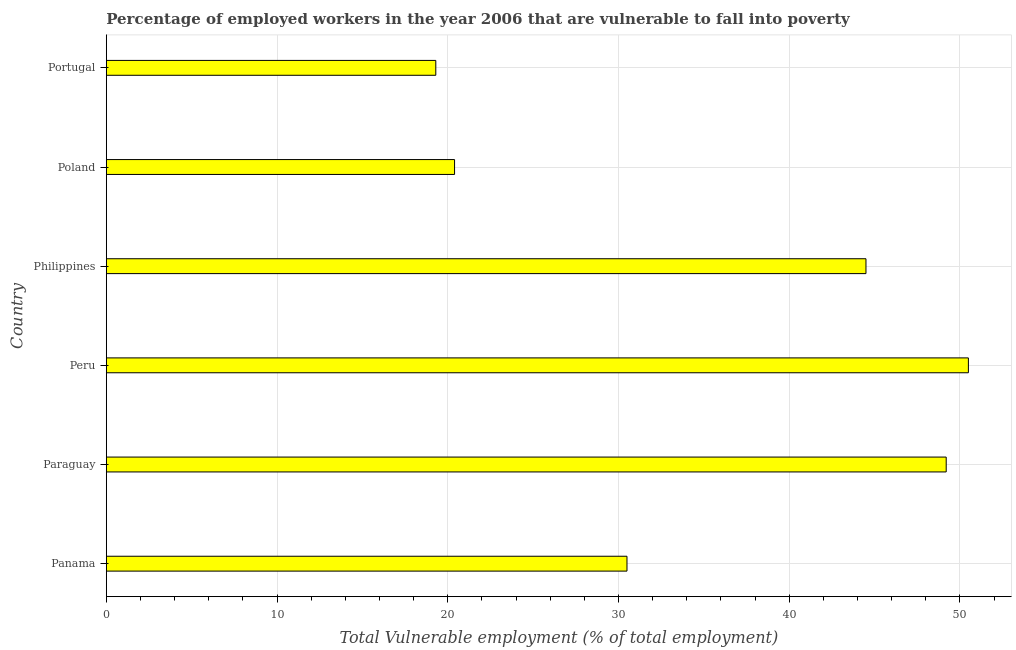Does the graph contain grids?
Offer a terse response. Yes. What is the title of the graph?
Make the answer very short. Percentage of employed workers in the year 2006 that are vulnerable to fall into poverty. What is the label or title of the X-axis?
Offer a very short reply. Total Vulnerable employment (% of total employment). What is the total vulnerable employment in Peru?
Offer a very short reply. 50.5. Across all countries, what is the maximum total vulnerable employment?
Your response must be concise. 50.5. Across all countries, what is the minimum total vulnerable employment?
Ensure brevity in your answer.  19.3. What is the sum of the total vulnerable employment?
Provide a succinct answer. 214.4. What is the average total vulnerable employment per country?
Ensure brevity in your answer.  35.73. What is the median total vulnerable employment?
Your response must be concise. 37.5. What is the difference between the highest and the second highest total vulnerable employment?
Your answer should be very brief. 1.3. Is the sum of the total vulnerable employment in Panama and Poland greater than the maximum total vulnerable employment across all countries?
Offer a very short reply. Yes. What is the difference between the highest and the lowest total vulnerable employment?
Your answer should be compact. 31.2. In how many countries, is the total vulnerable employment greater than the average total vulnerable employment taken over all countries?
Ensure brevity in your answer.  3. Are all the bars in the graph horizontal?
Ensure brevity in your answer.  Yes. Are the values on the major ticks of X-axis written in scientific E-notation?
Give a very brief answer. No. What is the Total Vulnerable employment (% of total employment) in Panama?
Provide a succinct answer. 30.5. What is the Total Vulnerable employment (% of total employment) in Paraguay?
Provide a short and direct response. 49.2. What is the Total Vulnerable employment (% of total employment) in Peru?
Make the answer very short. 50.5. What is the Total Vulnerable employment (% of total employment) of Philippines?
Your response must be concise. 44.5. What is the Total Vulnerable employment (% of total employment) in Poland?
Provide a succinct answer. 20.4. What is the Total Vulnerable employment (% of total employment) in Portugal?
Provide a short and direct response. 19.3. What is the difference between the Total Vulnerable employment (% of total employment) in Panama and Paraguay?
Provide a short and direct response. -18.7. What is the difference between the Total Vulnerable employment (% of total employment) in Panama and Peru?
Your answer should be compact. -20. What is the difference between the Total Vulnerable employment (% of total employment) in Paraguay and Philippines?
Offer a terse response. 4.7. What is the difference between the Total Vulnerable employment (% of total employment) in Paraguay and Poland?
Make the answer very short. 28.8. What is the difference between the Total Vulnerable employment (% of total employment) in Paraguay and Portugal?
Make the answer very short. 29.9. What is the difference between the Total Vulnerable employment (% of total employment) in Peru and Philippines?
Provide a short and direct response. 6. What is the difference between the Total Vulnerable employment (% of total employment) in Peru and Poland?
Make the answer very short. 30.1. What is the difference between the Total Vulnerable employment (% of total employment) in Peru and Portugal?
Provide a succinct answer. 31.2. What is the difference between the Total Vulnerable employment (% of total employment) in Philippines and Poland?
Give a very brief answer. 24.1. What is the difference between the Total Vulnerable employment (% of total employment) in Philippines and Portugal?
Your answer should be compact. 25.2. What is the difference between the Total Vulnerable employment (% of total employment) in Poland and Portugal?
Ensure brevity in your answer.  1.1. What is the ratio of the Total Vulnerable employment (% of total employment) in Panama to that in Paraguay?
Make the answer very short. 0.62. What is the ratio of the Total Vulnerable employment (% of total employment) in Panama to that in Peru?
Provide a succinct answer. 0.6. What is the ratio of the Total Vulnerable employment (% of total employment) in Panama to that in Philippines?
Keep it short and to the point. 0.69. What is the ratio of the Total Vulnerable employment (% of total employment) in Panama to that in Poland?
Provide a short and direct response. 1.5. What is the ratio of the Total Vulnerable employment (% of total employment) in Panama to that in Portugal?
Keep it short and to the point. 1.58. What is the ratio of the Total Vulnerable employment (% of total employment) in Paraguay to that in Peru?
Your response must be concise. 0.97. What is the ratio of the Total Vulnerable employment (% of total employment) in Paraguay to that in Philippines?
Ensure brevity in your answer.  1.11. What is the ratio of the Total Vulnerable employment (% of total employment) in Paraguay to that in Poland?
Offer a terse response. 2.41. What is the ratio of the Total Vulnerable employment (% of total employment) in Paraguay to that in Portugal?
Provide a succinct answer. 2.55. What is the ratio of the Total Vulnerable employment (% of total employment) in Peru to that in Philippines?
Your response must be concise. 1.14. What is the ratio of the Total Vulnerable employment (% of total employment) in Peru to that in Poland?
Offer a very short reply. 2.48. What is the ratio of the Total Vulnerable employment (% of total employment) in Peru to that in Portugal?
Your answer should be very brief. 2.62. What is the ratio of the Total Vulnerable employment (% of total employment) in Philippines to that in Poland?
Offer a very short reply. 2.18. What is the ratio of the Total Vulnerable employment (% of total employment) in Philippines to that in Portugal?
Provide a short and direct response. 2.31. What is the ratio of the Total Vulnerable employment (% of total employment) in Poland to that in Portugal?
Provide a short and direct response. 1.06. 